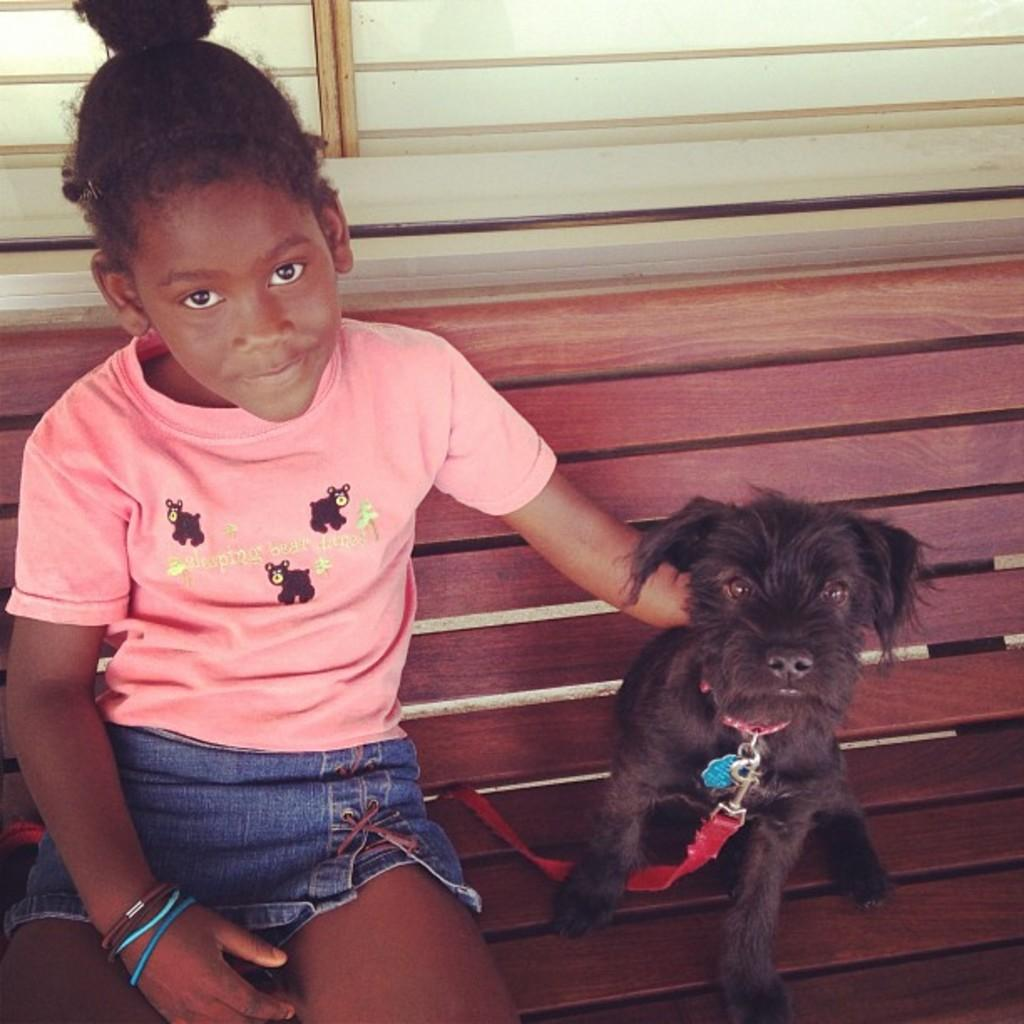What type of chair is in the image? There is a brown chair in the image. Who is sitting on the chair? A girl is sitting on the chair. What is the girl holding in the image? The girl is holding a black dog. What can be seen behind the chair and the girl? There is a white wall in the background of the image. Are there any fairies visible in the image? No, there are no fairies present in the image. What type of gardening tool is the girl using in the image? There is no gardening tool, such as a spade, present in the image. 